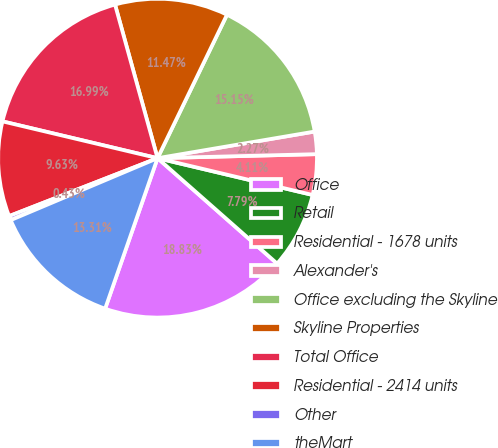Convert chart. <chart><loc_0><loc_0><loc_500><loc_500><pie_chart><fcel>Office<fcel>Retail<fcel>Residential - 1678 units<fcel>Alexander's<fcel>Office excluding the Skyline<fcel>Skyline Properties<fcel>Total Office<fcel>Residential - 2414 units<fcel>Other<fcel>theMart<nl><fcel>18.83%<fcel>7.79%<fcel>4.11%<fcel>2.27%<fcel>15.15%<fcel>11.47%<fcel>16.99%<fcel>9.63%<fcel>0.43%<fcel>13.31%<nl></chart> 